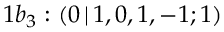<formula> <loc_0><loc_0><loc_500><loc_500>1 b _ { 3 } \colon ( 0 \, | \, 1 , 0 , 1 , - 1 ; 1 )</formula> 